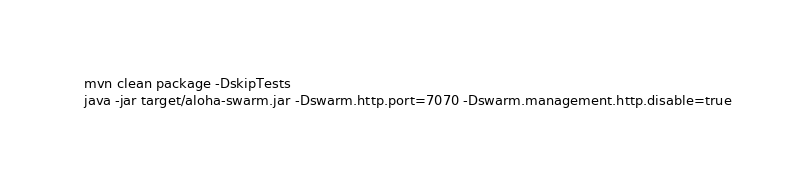<code> <loc_0><loc_0><loc_500><loc_500><_Bash_>mvn clean package -DskipTests
java -jar target/aloha-swarm.jar -Dswarm.http.port=7070 -Dswarm.management.http.disable=true
</code> 